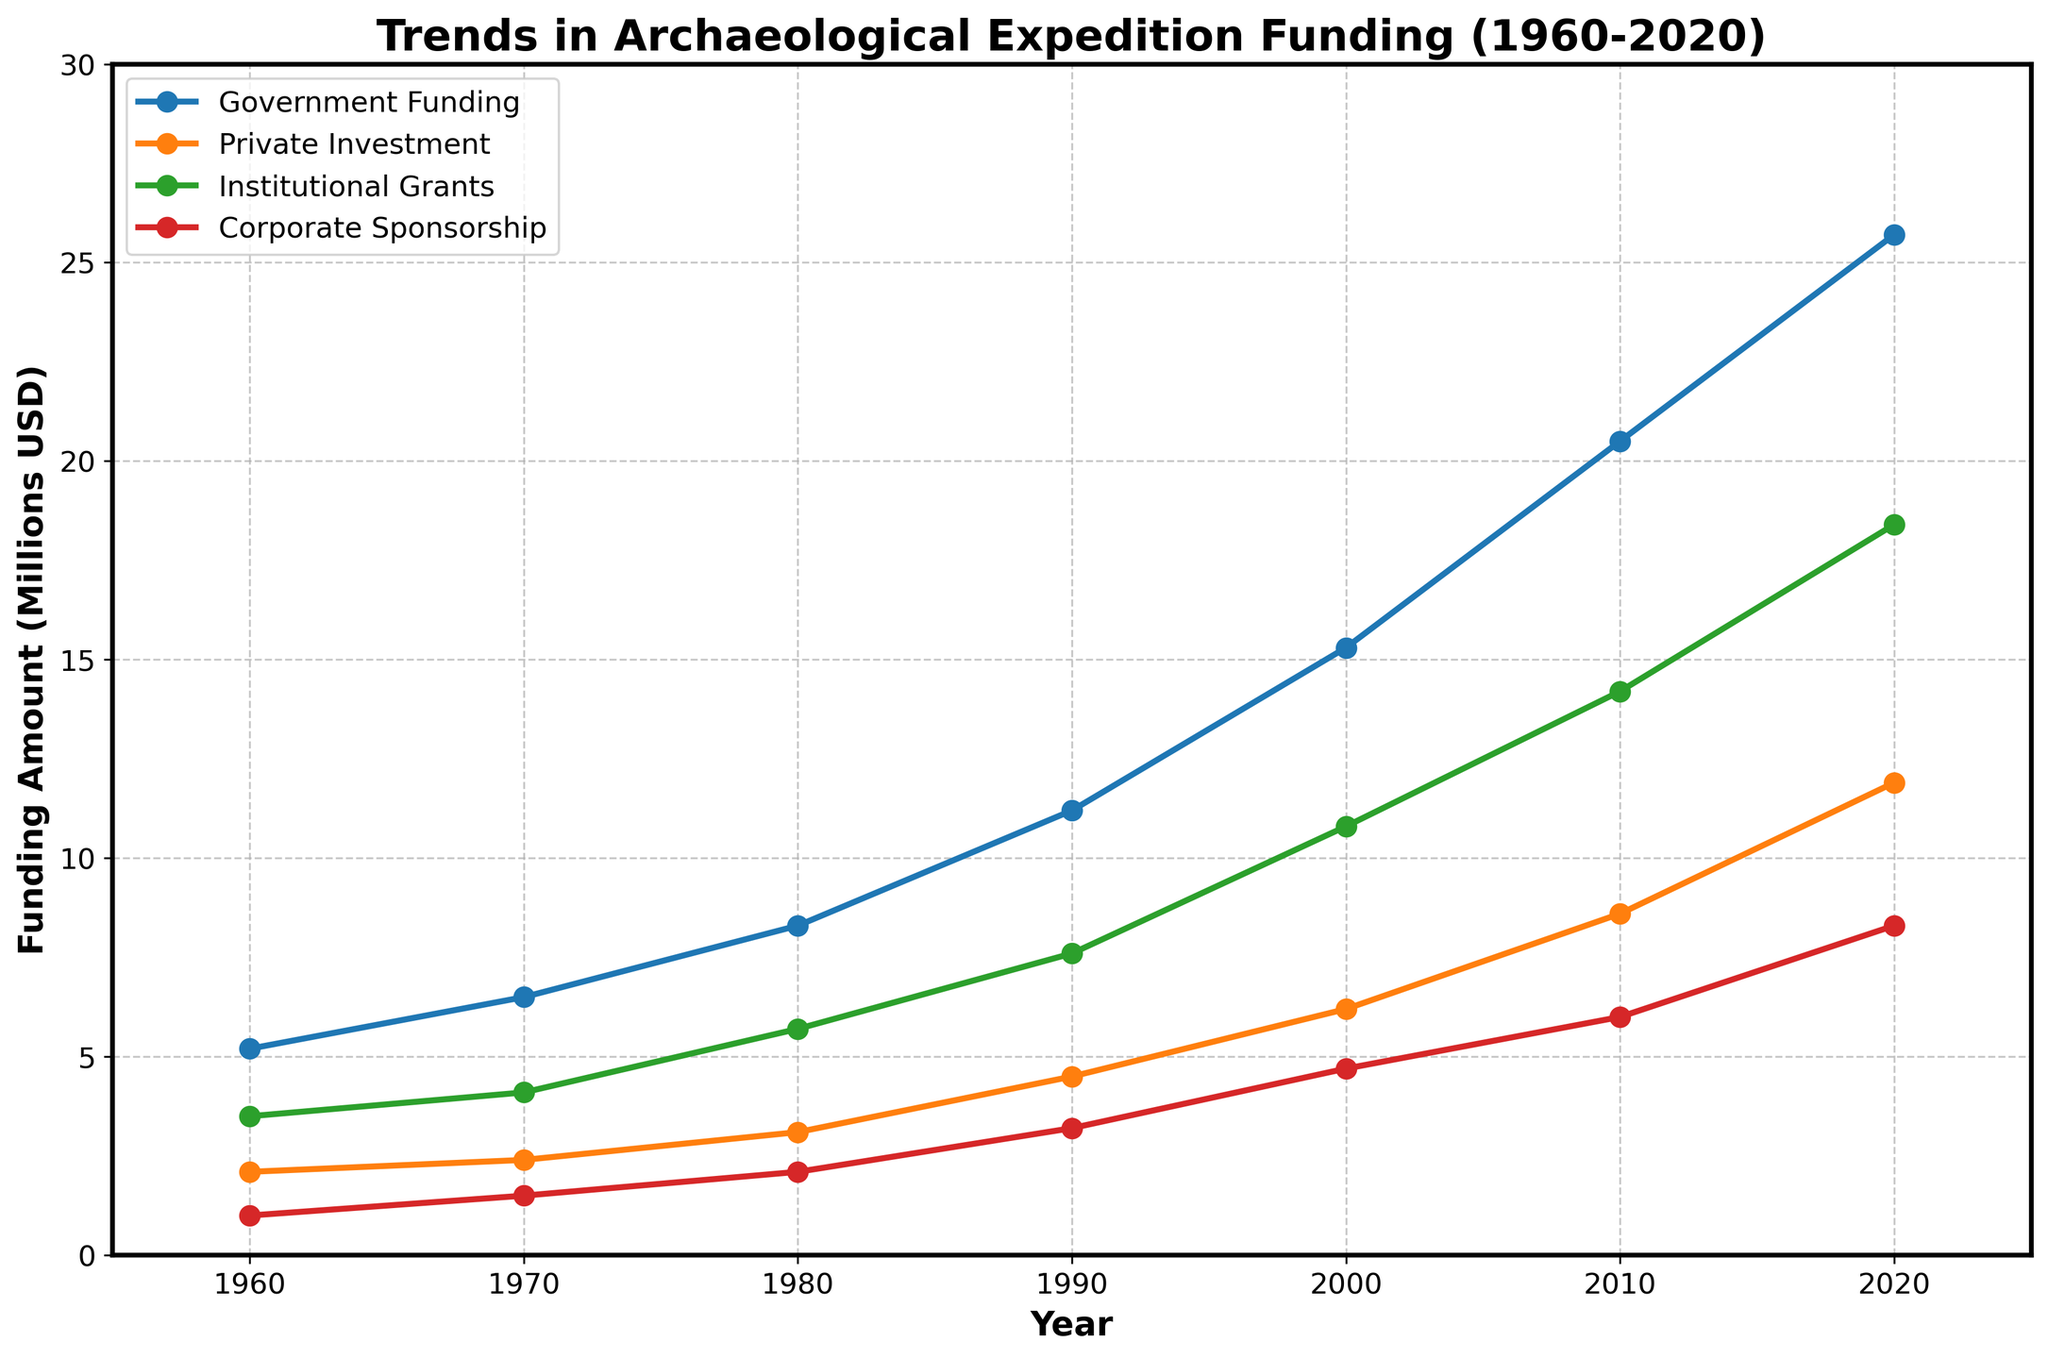What is the title of the figure? The title of the figure is usually at the top and it states the main theme or topic of the plot. In this case, the title is "Trends in Archaeological Expedition Funding (1960-2020)".
Answer: Trends in Archaeological Expedition Funding (1960-2020) How many funding sources are shown in the plot? The figure shows different funding sources, which can be seen in the legend or by looking at different colored lines. Here, there are four sources listed: Government Funding, Private Investment, Institutional Grants, and Corporate Sponsorship.
Answer: Four Which funding source had the highest amount in 2020? To find the highest funding amount in 2020, look at the values at the plot point for the year 2020 for all funding sources. Government Funding has the highest amount at this point, reaching 25.7 million USD.
Answer: Government Funding By how much did Institutional Grants increase from 1960 to 2020? To find the increase, subtract the value of Institutional Grants in 1960 from its value in 2020. Institutional Grants increased from 3.5 million USD in 1960 to 18.4 million USD in 2020. The calculation is 18.4 - 3.5.
Answer: 14.9 million USD What was the trend in Corporate Sponsorship from 1960 to 2020? Look at the line representing Corporate Sponsorship on the plot from 1960 to 2020. The plot shows an increasing trend in Corporate Sponsorship, from 1 million USD in 1960 to 8.3 million USD in 2020.
Answer: Increasing Between which two consecutive decades did Government Funding increase the most? Look at the Government Funding line and check the values between each decade. The biggest increase seems to be between 2000 (15.3 million USD) and 2010 (20.5 million USD). The increase is 20.5 - 15.3.
Answer: 2000 and 2010 What is the average amount of Private Investment from 1960 to 2020? Add up the Private Investment values for each decade (2.1, 2.4, 3.1, 4.5, 6.2, 8.6, 11.9) and then divide by the number of data points (7). The sum is 38.8, and the average is 38.8/7.
Answer: 5.54 million USD Which funding source saw the smallest increase over the period 1960 to 2020? For each funding source, subtract the 1960 value from the 2020 value and compare the differences. Calculations: Government Funding (25.7 - 5.2 = 20.5), Private Investment (11.9 - 2.1 = 9.8), Institutional Grants (18.4 - 3.5 = 14.9), Corporate Sponsorship (8.3 - 1.0 = 7.3). The smallest increase is in Corporate Sponsorship.
Answer: Corporate Sponsorship How does the funding from Private Investment in 1990 compare to Institutional Grants in 2000? Compare the values by checking the specific years. In 1990, Private Investment is 4.5 million USD, and in 2000, Institutional Grants are 10.8 million USD.
Answer: Institutional Grants in 2000 are higher 